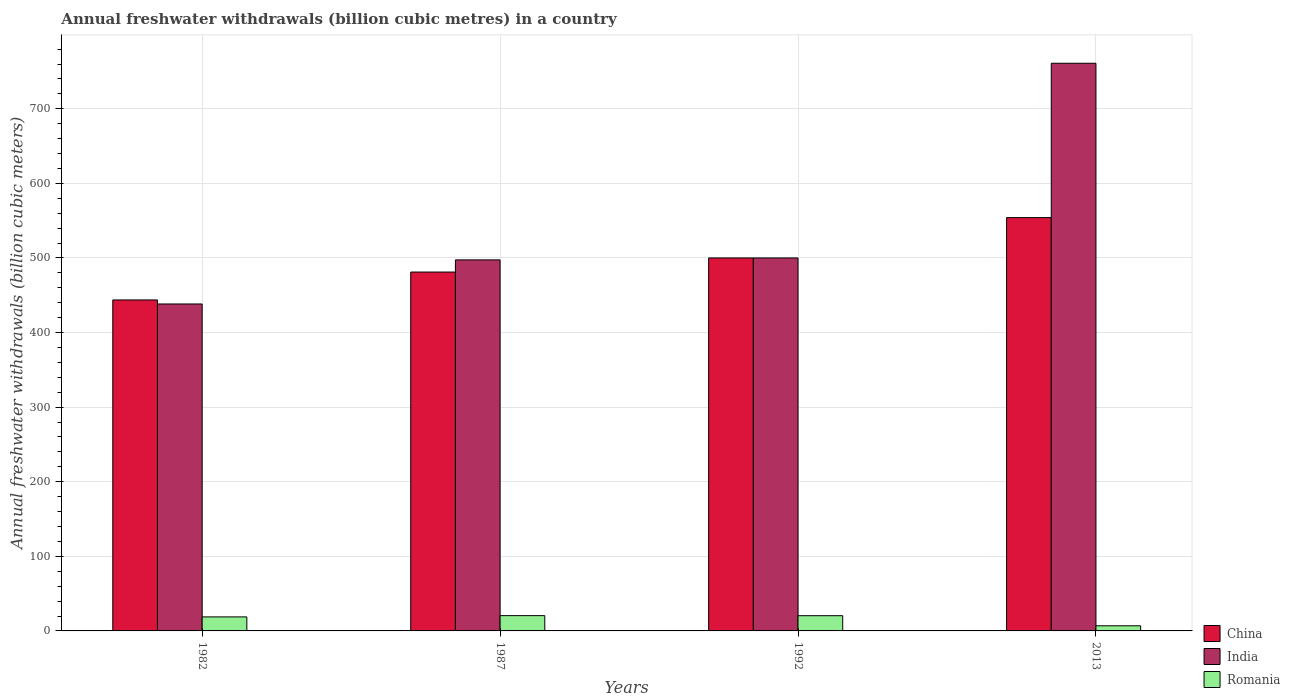How many different coloured bars are there?
Your answer should be very brief. 3. How many groups of bars are there?
Offer a very short reply. 4. What is the annual freshwater withdrawals in Romania in 2013?
Provide a short and direct response. 6.88. Across all years, what is the maximum annual freshwater withdrawals in India?
Offer a very short reply. 761. Across all years, what is the minimum annual freshwater withdrawals in India?
Keep it short and to the point. 438.3. What is the total annual freshwater withdrawals in India in the graph?
Offer a very short reply. 2196.7. What is the difference between the annual freshwater withdrawals in Romania in 1987 and that in 1992?
Offer a very short reply. 0.09. What is the difference between the annual freshwater withdrawals in India in 1992 and the annual freshwater withdrawals in China in 1987?
Your response must be concise. 18.9. What is the average annual freshwater withdrawals in India per year?
Ensure brevity in your answer.  549.17. In the year 1982, what is the difference between the annual freshwater withdrawals in China and annual freshwater withdrawals in India?
Provide a succinct answer. 5.4. What is the ratio of the annual freshwater withdrawals in Romania in 1982 to that in 1992?
Provide a succinct answer. 0.92. Is the difference between the annual freshwater withdrawals in China in 1982 and 1987 greater than the difference between the annual freshwater withdrawals in India in 1982 and 1987?
Your answer should be compact. Yes. What is the difference between the highest and the second highest annual freshwater withdrawals in Romania?
Offer a very short reply. 0.09. What is the difference between the highest and the lowest annual freshwater withdrawals in India?
Offer a terse response. 322.7. How many bars are there?
Provide a succinct answer. 12. Are the values on the major ticks of Y-axis written in scientific E-notation?
Provide a short and direct response. No. How many legend labels are there?
Provide a succinct answer. 3. How are the legend labels stacked?
Provide a succinct answer. Vertical. What is the title of the graph?
Offer a terse response. Annual freshwater withdrawals (billion cubic metres) in a country. Does "Central African Republic" appear as one of the legend labels in the graph?
Make the answer very short. No. What is the label or title of the X-axis?
Your response must be concise. Years. What is the label or title of the Y-axis?
Give a very brief answer. Annual freshwater withdrawals (billion cubic meters). What is the Annual freshwater withdrawals (billion cubic meters) in China in 1982?
Your answer should be very brief. 443.7. What is the Annual freshwater withdrawals (billion cubic meters) of India in 1982?
Provide a short and direct response. 438.3. What is the Annual freshwater withdrawals (billion cubic meters) of China in 1987?
Offer a terse response. 481.1. What is the Annual freshwater withdrawals (billion cubic meters) in India in 1987?
Make the answer very short. 497.4. What is the Annual freshwater withdrawals (billion cubic meters) in India in 1992?
Your response must be concise. 500. What is the Annual freshwater withdrawals (billion cubic meters) of Romania in 1992?
Ensure brevity in your answer.  20.41. What is the Annual freshwater withdrawals (billion cubic meters) of China in 2013?
Your answer should be compact. 554.1. What is the Annual freshwater withdrawals (billion cubic meters) in India in 2013?
Make the answer very short. 761. What is the Annual freshwater withdrawals (billion cubic meters) in Romania in 2013?
Give a very brief answer. 6.88. Across all years, what is the maximum Annual freshwater withdrawals (billion cubic meters) of China?
Ensure brevity in your answer.  554.1. Across all years, what is the maximum Annual freshwater withdrawals (billion cubic meters) of India?
Provide a succinct answer. 761. Across all years, what is the minimum Annual freshwater withdrawals (billion cubic meters) in China?
Your answer should be compact. 443.7. Across all years, what is the minimum Annual freshwater withdrawals (billion cubic meters) in India?
Provide a short and direct response. 438.3. Across all years, what is the minimum Annual freshwater withdrawals (billion cubic meters) in Romania?
Your answer should be compact. 6.88. What is the total Annual freshwater withdrawals (billion cubic meters) in China in the graph?
Keep it short and to the point. 1978.9. What is the total Annual freshwater withdrawals (billion cubic meters) in India in the graph?
Offer a very short reply. 2196.7. What is the total Annual freshwater withdrawals (billion cubic meters) in Romania in the graph?
Provide a short and direct response. 66.59. What is the difference between the Annual freshwater withdrawals (billion cubic meters) in China in 1982 and that in 1987?
Provide a short and direct response. -37.4. What is the difference between the Annual freshwater withdrawals (billion cubic meters) of India in 1982 and that in 1987?
Make the answer very short. -59.1. What is the difference between the Annual freshwater withdrawals (billion cubic meters) of Romania in 1982 and that in 1987?
Your answer should be very brief. -1.7. What is the difference between the Annual freshwater withdrawals (billion cubic meters) in China in 1982 and that in 1992?
Your answer should be compact. -56.3. What is the difference between the Annual freshwater withdrawals (billion cubic meters) of India in 1982 and that in 1992?
Offer a terse response. -61.7. What is the difference between the Annual freshwater withdrawals (billion cubic meters) in Romania in 1982 and that in 1992?
Offer a terse response. -1.61. What is the difference between the Annual freshwater withdrawals (billion cubic meters) in China in 1982 and that in 2013?
Make the answer very short. -110.4. What is the difference between the Annual freshwater withdrawals (billion cubic meters) in India in 1982 and that in 2013?
Your answer should be compact. -322.7. What is the difference between the Annual freshwater withdrawals (billion cubic meters) of Romania in 1982 and that in 2013?
Your answer should be compact. 11.92. What is the difference between the Annual freshwater withdrawals (billion cubic meters) of China in 1987 and that in 1992?
Provide a succinct answer. -18.9. What is the difference between the Annual freshwater withdrawals (billion cubic meters) of Romania in 1987 and that in 1992?
Give a very brief answer. 0.09. What is the difference between the Annual freshwater withdrawals (billion cubic meters) in China in 1987 and that in 2013?
Offer a very short reply. -73. What is the difference between the Annual freshwater withdrawals (billion cubic meters) in India in 1987 and that in 2013?
Your answer should be compact. -263.6. What is the difference between the Annual freshwater withdrawals (billion cubic meters) in Romania in 1987 and that in 2013?
Keep it short and to the point. 13.62. What is the difference between the Annual freshwater withdrawals (billion cubic meters) in China in 1992 and that in 2013?
Keep it short and to the point. -54.1. What is the difference between the Annual freshwater withdrawals (billion cubic meters) in India in 1992 and that in 2013?
Keep it short and to the point. -261. What is the difference between the Annual freshwater withdrawals (billion cubic meters) in Romania in 1992 and that in 2013?
Your response must be concise. 13.53. What is the difference between the Annual freshwater withdrawals (billion cubic meters) of China in 1982 and the Annual freshwater withdrawals (billion cubic meters) of India in 1987?
Offer a very short reply. -53.7. What is the difference between the Annual freshwater withdrawals (billion cubic meters) in China in 1982 and the Annual freshwater withdrawals (billion cubic meters) in Romania in 1987?
Your response must be concise. 423.2. What is the difference between the Annual freshwater withdrawals (billion cubic meters) in India in 1982 and the Annual freshwater withdrawals (billion cubic meters) in Romania in 1987?
Your answer should be very brief. 417.8. What is the difference between the Annual freshwater withdrawals (billion cubic meters) of China in 1982 and the Annual freshwater withdrawals (billion cubic meters) of India in 1992?
Give a very brief answer. -56.3. What is the difference between the Annual freshwater withdrawals (billion cubic meters) in China in 1982 and the Annual freshwater withdrawals (billion cubic meters) in Romania in 1992?
Your answer should be very brief. 423.29. What is the difference between the Annual freshwater withdrawals (billion cubic meters) of India in 1982 and the Annual freshwater withdrawals (billion cubic meters) of Romania in 1992?
Your response must be concise. 417.89. What is the difference between the Annual freshwater withdrawals (billion cubic meters) of China in 1982 and the Annual freshwater withdrawals (billion cubic meters) of India in 2013?
Offer a very short reply. -317.3. What is the difference between the Annual freshwater withdrawals (billion cubic meters) in China in 1982 and the Annual freshwater withdrawals (billion cubic meters) in Romania in 2013?
Provide a short and direct response. 436.82. What is the difference between the Annual freshwater withdrawals (billion cubic meters) in India in 1982 and the Annual freshwater withdrawals (billion cubic meters) in Romania in 2013?
Your response must be concise. 431.42. What is the difference between the Annual freshwater withdrawals (billion cubic meters) in China in 1987 and the Annual freshwater withdrawals (billion cubic meters) in India in 1992?
Offer a terse response. -18.9. What is the difference between the Annual freshwater withdrawals (billion cubic meters) in China in 1987 and the Annual freshwater withdrawals (billion cubic meters) in Romania in 1992?
Offer a very short reply. 460.69. What is the difference between the Annual freshwater withdrawals (billion cubic meters) in India in 1987 and the Annual freshwater withdrawals (billion cubic meters) in Romania in 1992?
Your answer should be compact. 476.99. What is the difference between the Annual freshwater withdrawals (billion cubic meters) in China in 1987 and the Annual freshwater withdrawals (billion cubic meters) in India in 2013?
Your answer should be compact. -279.9. What is the difference between the Annual freshwater withdrawals (billion cubic meters) of China in 1987 and the Annual freshwater withdrawals (billion cubic meters) of Romania in 2013?
Ensure brevity in your answer.  474.22. What is the difference between the Annual freshwater withdrawals (billion cubic meters) in India in 1987 and the Annual freshwater withdrawals (billion cubic meters) in Romania in 2013?
Offer a terse response. 490.52. What is the difference between the Annual freshwater withdrawals (billion cubic meters) of China in 1992 and the Annual freshwater withdrawals (billion cubic meters) of India in 2013?
Your answer should be compact. -261. What is the difference between the Annual freshwater withdrawals (billion cubic meters) of China in 1992 and the Annual freshwater withdrawals (billion cubic meters) of Romania in 2013?
Your answer should be compact. 493.12. What is the difference between the Annual freshwater withdrawals (billion cubic meters) in India in 1992 and the Annual freshwater withdrawals (billion cubic meters) in Romania in 2013?
Your response must be concise. 493.12. What is the average Annual freshwater withdrawals (billion cubic meters) of China per year?
Offer a very short reply. 494.73. What is the average Annual freshwater withdrawals (billion cubic meters) in India per year?
Your response must be concise. 549.17. What is the average Annual freshwater withdrawals (billion cubic meters) in Romania per year?
Keep it short and to the point. 16.65. In the year 1982, what is the difference between the Annual freshwater withdrawals (billion cubic meters) of China and Annual freshwater withdrawals (billion cubic meters) of Romania?
Offer a terse response. 424.9. In the year 1982, what is the difference between the Annual freshwater withdrawals (billion cubic meters) in India and Annual freshwater withdrawals (billion cubic meters) in Romania?
Your response must be concise. 419.5. In the year 1987, what is the difference between the Annual freshwater withdrawals (billion cubic meters) of China and Annual freshwater withdrawals (billion cubic meters) of India?
Your answer should be very brief. -16.3. In the year 1987, what is the difference between the Annual freshwater withdrawals (billion cubic meters) in China and Annual freshwater withdrawals (billion cubic meters) in Romania?
Make the answer very short. 460.6. In the year 1987, what is the difference between the Annual freshwater withdrawals (billion cubic meters) in India and Annual freshwater withdrawals (billion cubic meters) in Romania?
Your answer should be very brief. 476.9. In the year 1992, what is the difference between the Annual freshwater withdrawals (billion cubic meters) of China and Annual freshwater withdrawals (billion cubic meters) of India?
Give a very brief answer. 0. In the year 1992, what is the difference between the Annual freshwater withdrawals (billion cubic meters) in China and Annual freshwater withdrawals (billion cubic meters) in Romania?
Your response must be concise. 479.59. In the year 1992, what is the difference between the Annual freshwater withdrawals (billion cubic meters) of India and Annual freshwater withdrawals (billion cubic meters) of Romania?
Your response must be concise. 479.59. In the year 2013, what is the difference between the Annual freshwater withdrawals (billion cubic meters) of China and Annual freshwater withdrawals (billion cubic meters) of India?
Provide a succinct answer. -206.9. In the year 2013, what is the difference between the Annual freshwater withdrawals (billion cubic meters) of China and Annual freshwater withdrawals (billion cubic meters) of Romania?
Offer a terse response. 547.22. In the year 2013, what is the difference between the Annual freshwater withdrawals (billion cubic meters) of India and Annual freshwater withdrawals (billion cubic meters) of Romania?
Provide a succinct answer. 754.12. What is the ratio of the Annual freshwater withdrawals (billion cubic meters) of China in 1982 to that in 1987?
Your answer should be very brief. 0.92. What is the ratio of the Annual freshwater withdrawals (billion cubic meters) in India in 1982 to that in 1987?
Ensure brevity in your answer.  0.88. What is the ratio of the Annual freshwater withdrawals (billion cubic meters) in Romania in 1982 to that in 1987?
Offer a very short reply. 0.92. What is the ratio of the Annual freshwater withdrawals (billion cubic meters) in China in 1982 to that in 1992?
Your answer should be very brief. 0.89. What is the ratio of the Annual freshwater withdrawals (billion cubic meters) in India in 1982 to that in 1992?
Offer a very short reply. 0.88. What is the ratio of the Annual freshwater withdrawals (billion cubic meters) in Romania in 1982 to that in 1992?
Keep it short and to the point. 0.92. What is the ratio of the Annual freshwater withdrawals (billion cubic meters) in China in 1982 to that in 2013?
Offer a terse response. 0.8. What is the ratio of the Annual freshwater withdrawals (billion cubic meters) of India in 1982 to that in 2013?
Offer a terse response. 0.58. What is the ratio of the Annual freshwater withdrawals (billion cubic meters) of Romania in 1982 to that in 2013?
Offer a terse response. 2.73. What is the ratio of the Annual freshwater withdrawals (billion cubic meters) of China in 1987 to that in 1992?
Make the answer very short. 0.96. What is the ratio of the Annual freshwater withdrawals (billion cubic meters) in China in 1987 to that in 2013?
Your answer should be compact. 0.87. What is the ratio of the Annual freshwater withdrawals (billion cubic meters) of India in 1987 to that in 2013?
Provide a succinct answer. 0.65. What is the ratio of the Annual freshwater withdrawals (billion cubic meters) of Romania in 1987 to that in 2013?
Make the answer very short. 2.98. What is the ratio of the Annual freshwater withdrawals (billion cubic meters) in China in 1992 to that in 2013?
Your answer should be very brief. 0.9. What is the ratio of the Annual freshwater withdrawals (billion cubic meters) of India in 1992 to that in 2013?
Give a very brief answer. 0.66. What is the ratio of the Annual freshwater withdrawals (billion cubic meters) of Romania in 1992 to that in 2013?
Provide a succinct answer. 2.97. What is the difference between the highest and the second highest Annual freshwater withdrawals (billion cubic meters) in China?
Make the answer very short. 54.1. What is the difference between the highest and the second highest Annual freshwater withdrawals (billion cubic meters) in India?
Provide a short and direct response. 261. What is the difference between the highest and the second highest Annual freshwater withdrawals (billion cubic meters) in Romania?
Your answer should be compact. 0.09. What is the difference between the highest and the lowest Annual freshwater withdrawals (billion cubic meters) in China?
Offer a terse response. 110.4. What is the difference between the highest and the lowest Annual freshwater withdrawals (billion cubic meters) of India?
Your answer should be compact. 322.7. What is the difference between the highest and the lowest Annual freshwater withdrawals (billion cubic meters) of Romania?
Your response must be concise. 13.62. 